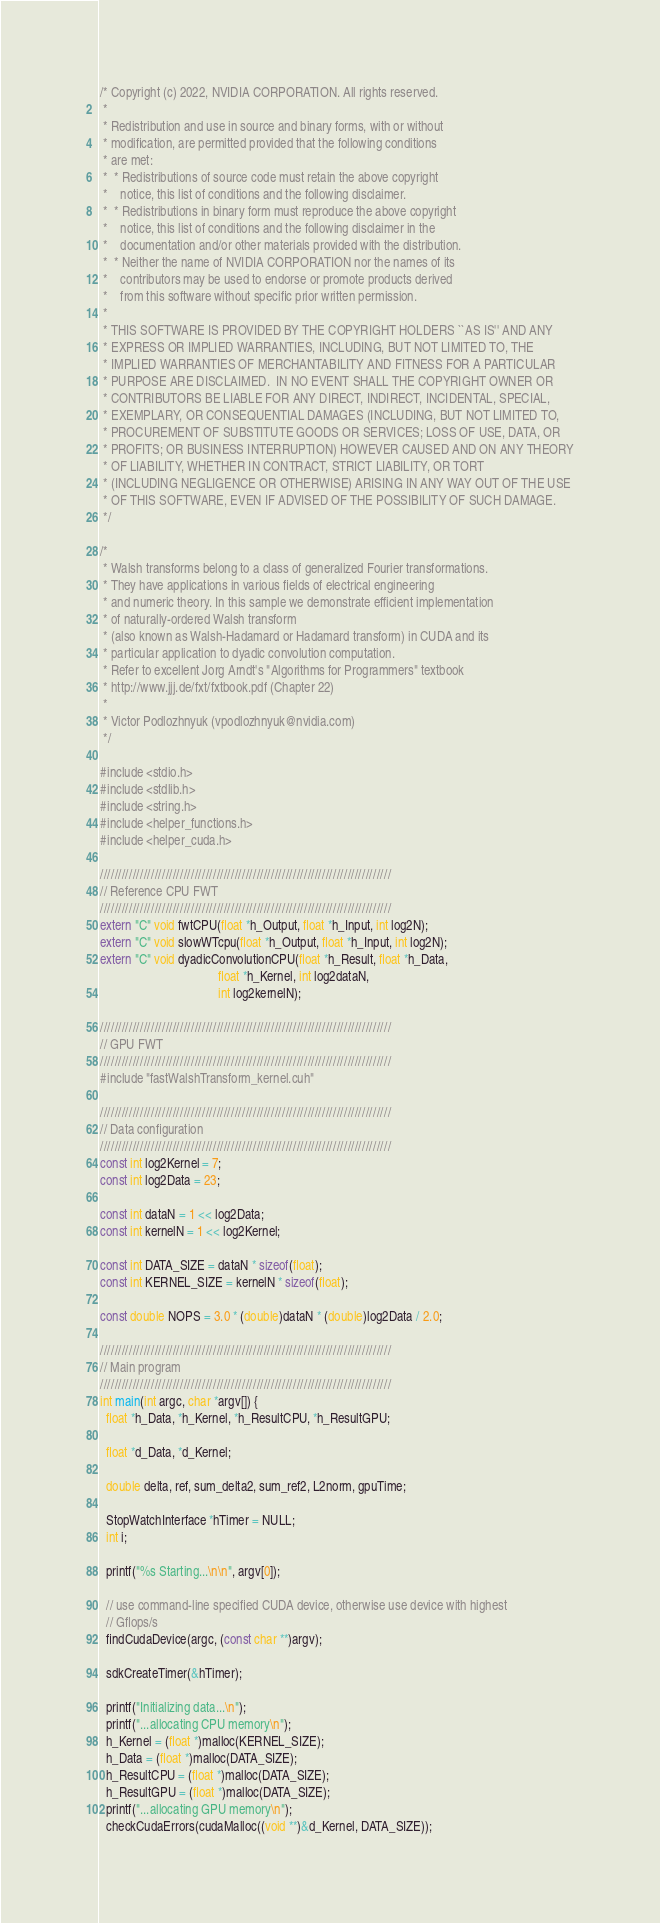<code> <loc_0><loc_0><loc_500><loc_500><_Cuda_>/* Copyright (c) 2022, NVIDIA CORPORATION. All rights reserved.
 *
 * Redistribution and use in source and binary forms, with or without
 * modification, are permitted provided that the following conditions
 * are met:
 *  * Redistributions of source code must retain the above copyright
 *    notice, this list of conditions and the following disclaimer.
 *  * Redistributions in binary form must reproduce the above copyright
 *    notice, this list of conditions and the following disclaimer in the
 *    documentation and/or other materials provided with the distribution.
 *  * Neither the name of NVIDIA CORPORATION nor the names of its
 *    contributors may be used to endorse or promote products derived
 *    from this software without specific prior written permission.
 *
 * THIS SOFTWARE IS PROVIDED BY THE COPYRIGHT HOLDERS ``AS IS'' AND ANY
 * EXPRESS OR IMPLIED WARRANTIES, INCLUDING, BUT NOT LIMITED TO, THE
 * IMPLIED WARRANTIES OF MERCHANTABILITY AND FITNESS FOR A PARTICULAR
 * PURPOSE ARE DISCLAIMED.  IN NO EVENT SHALL THE COPYRIGHT OWNER OR
 * CONTRIBUTORS BE LIABLE FOR ANY DIRECT, INDIRECT, INCIDENTAL, SPECIAL,
 * EXEMPLARY, OR CONSEQUENTIAL DAMAGES (INCLUDING, BUT NOT LIMITED TO,
 * PROCUREMENT OF SUBSTITUTE GOODS OR SERVICES; LOSS OF USE, DATA, OR
 * PROFITS; OR BUSINESS INTERRUPTION) HOWEVER CAUSED AND ON ANY THEORY
 * OF LIABILITY, WHETHER IN CONTRACT, STRICT LIABILITY, OR TORT
 * (INCLUDING NEGLIGENCE OR OTHERWISE) ARISING IN ANY WAY OUT OF THE USE
 * OF THIS SOFTWARE, EVEN IF ADVISED OF THE POSSIBILITY OF SUCH DAMAGE.
 */

/*
 * Walsh transforms belong to a class of generalized Fourier transformations.
 * They have applications in various fields of electrical engineering
 * and numeric theory. In this sample we demonstrate efficient implementation
 * of naturally-ordered Walsh transform
 * (also known as Walsh-Hadamard or Hadamard transform) in CUDA and its
 * particular application to dyadic convolution computation.
 * Refer to excellent Jorg Arndt's "Algorithms for Programmers" textbook
 * http://www.jjj.de/fxt/fxtbook.pdf (Chapter 22)
 *
 * Victor Podlozhnyuk (vpodlozhnyuk@nvidia.com)
 */

#include <stdio.h>
#include <stdlib.h>
#include <string.h>
#include <helper_functions.h>
#include <helper_cuda.h>

////////////////////////////////////////////////////////////////////////////////
// Reference CPU FWT
////////////////////////////////////////////////////////////////////////////////
extern "C" void fwtCPU(float *h_Output, float *h_Input, int log2N);
extern "C" void slowWTcpu(float *h_Output, float *h_Input, int log2N);
extern "C" void dyadicConvolutionCPU(float *h_Result, float *h_Data,
                                     float *h_Kernel, int log2dataN,
                                     int log2kernelN);

////////////////////////////////////////////////////////////////////////////////
// GPU FWT
////////////////////////////////////////////////////////////////////////////////
#include "fastWalshTransform_kernel.cuh"

////////////////////////////////////////////////////////////////////////////////
// Data configuration
////////////////////////////////////////////////////////////////////////////////
const int log2Kernel = 7;
const int log2Data = 23;

const int dataN = 1 << log2Data;
const int kernelN = 1 << log2Kernel;

const int DATA_SIZE = dataN * sizeof(float);
const int KERNEL_SIZE = kernelN * sizeof(float);

const double NOPS = 3.0 * (double)dataN * (double)log2Data / 2.0;

////////////////////////////////////////////////////////////////////////////////
// Main program
////////////////////////////////////////////////////////////////////////////////
int main(int argc, char *argv[]) {
  float *h_Data, *h_Kernel, *h_ResultCPU, *h_ResultGPU;

  float *d_Data, *d_Kernel;

  double delta, ref, sum_delta2, sum_ref2, L2norm, gpuTime;

  StopWatchInterface *hTimer = NULL;
  int i;

  printf("%s Starting...\n\n", argv[0]);

  // use command-line specified CUDA device, otherwise use device with highest
  // Gflops/s
  findCudaDevice(argc, (const char **)argv);

  sdkCreateTimer(&hTimer);

  printf("Initializing data...\n");
  printf("...allocating CPU memory\n");
  h_Kernel = (float *)malloc(KERNEL_SIZE);
  h_Data = (float *)malloc(DATA_SIZE);
  h_ResultCPU = (float *)malloc(DATA_SIZE);
  h_ResultGPU = (float *)malloc(DATA_SIZE);
  printf("...allocating GPU memory\n");
  checkCudaErrors(cudaMalloc((void **)&d_Kernel, DATA_SIZE));</code> 